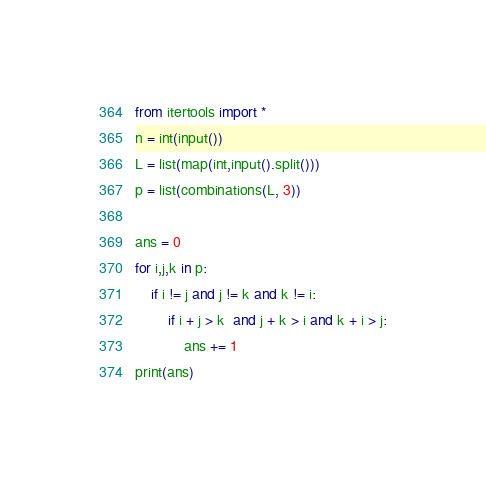Convert code to text. <code><loc_0><loc_0><loc_500><loc_500><_Python_>from itertools import * 
n = int(input())
L = list(map(int,input().split()))
p = list(combinations(L, 3))

ans = 0
for i,j,k in p:
    if i != j and j != k and k != i:
        if i + j > k  and j + k > i and k + i > j:
            ans += 1
print(ans)</code> 